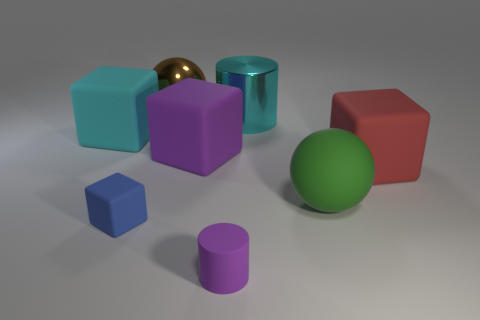Subtract 1 cubes. How many cubes are left? 3 Add 2 big brown rubber cylinders. How many objects exist? 10 Subtract all cylinders. How many objects are left? 6 Subtract all small blue cubes. Subtract all cyan cylinders. How many objects are left? 6 Add 2 tiny purple rubber cylinders. How many tiny purple rubber cylinders are left? 3 Add 3 big cyan matte objects. How many big cyan matte objects exist? 4 Subtract 0 blue spheres. How many objects are left? 8 